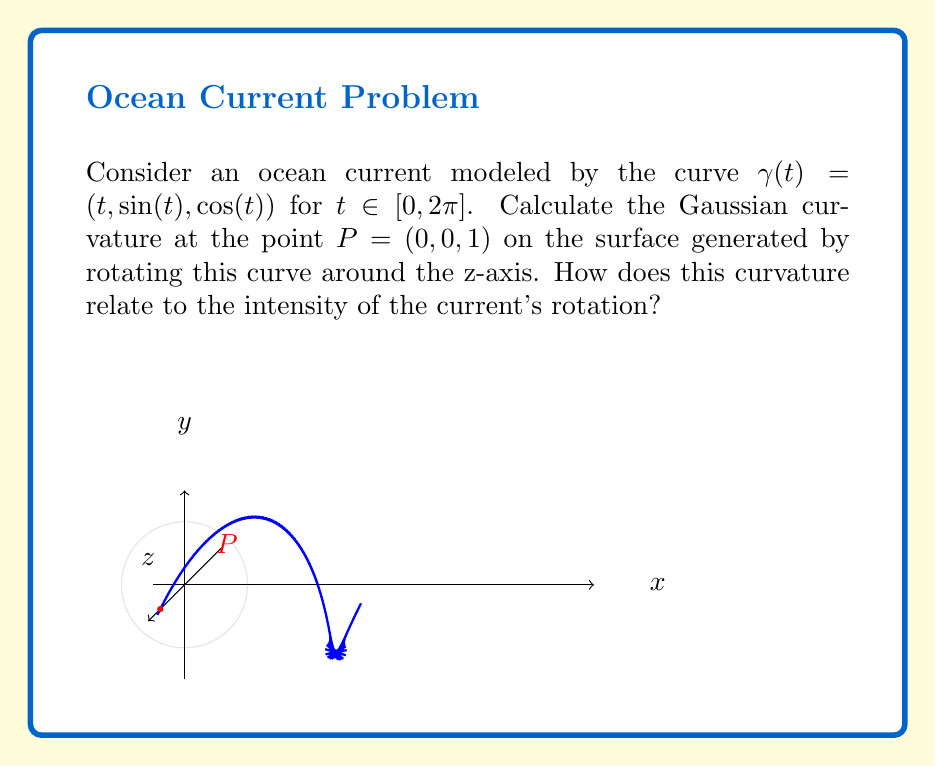Solve this math problem. To solve this problem, we'll follow these steps:

1) First, we need to parameterize the surface. Let $r(u,v) = (u, \sin(u)\cos(v), \cos(u)\cos(v))$ where $u \in [0, 2\pi]$ and $v \in [0, 2\pi]$.

2) Calculate the partial derivatives:
   $r_u = (1, \cos(u)\cos(v), -\sin(u)\cos(v))$
   $r_v = (0, -\sin(u)\sin(v), -\cos(u)\sin(v))$

3) Calculate the coefficients of the first fundamental form:
   $E = r_u \cdot r_u = 1 + \cos^2(v)$
   $F = r_u \cdot r_v = 0$
   $G = r_v \cdot r_v = \sin^2(v)$

4) Calculate the second partial derivatives:
   $r_{uu} = (0, -\sin(u)\cos(v), -\cos(u)\cos(v))$
   $r_{uv} = (0, -\cos(u)\sin(v), \sin(u)\sin(v))$
   $r_{vv} = (0, -\sin(u)\cos(v), -\cos(u)\cos(v))$

5) Calculate the normal vector:
   $N = \frac{r_u \times r_v}{|r_u \times r_v|} = (\cos(v), -\sin(u), \cos(u))$

6) Calculate the coefficients of the second fundamental form:
   $L = r_{uu} \cdot N = \cos(v)$
   $M = r_{uv} \cdot N = 0$
   $N = r_{vv} \cdot N = \cos(v)$

7) The Gaussian curvature is given by:
   $K = \frac{LN - M^2}{EG - F^2} = \frac{\cos^2(v)}{(1 + \cos^2(v))\sin^2(v)}$

8) At the point $P(0, 0, 1)$, we have $u = 0$ and $v = 0$. Substituting these values:
   $K = \frac{1}{1} = 1$

9) The positive Gaussian curvature indicates that the surface is locally elliptic at this point, which corresponds to a clockwise rotation of the current. The magnitude of 1 suggests a moderate intensity of rotation.
Answer: $K = 1$, indicating moderate clockwise rotation. 